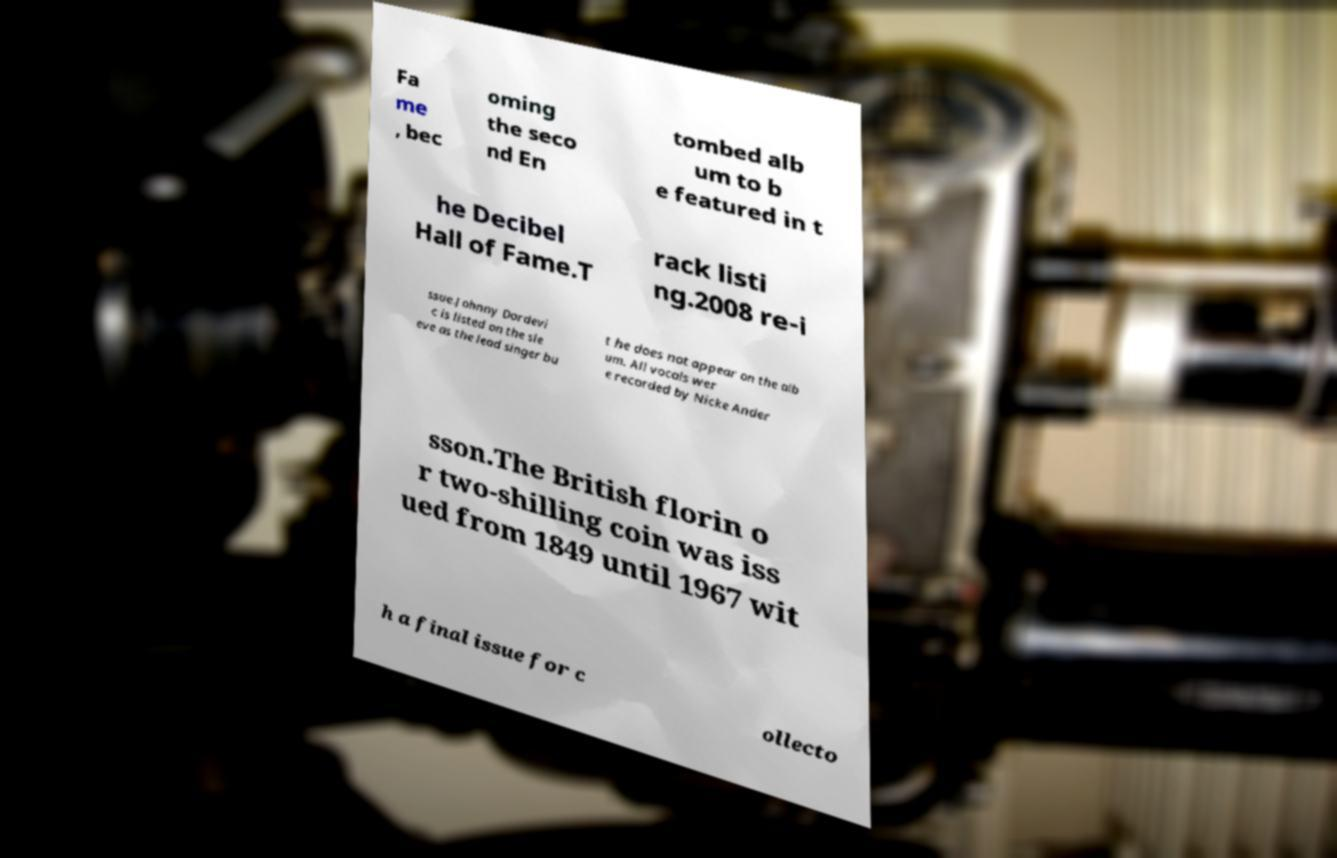I need the written content from this picture converted into text. Can you do that? Fa me , bec oming the seco nd En tombed alb um to b e featured in t he Decibel Hall of Fame.T rack listi ng.2008 re-i ssue.Johnny Dordevi c is listed on the sle eve as the lead singer bu t he does not appear on the alb um. All vocals wer e recorded by Nicke Ander sson.The British florin o r two-shilling coin was iss ued from 1849 until 1967 wit h a final issue for c ollecto 